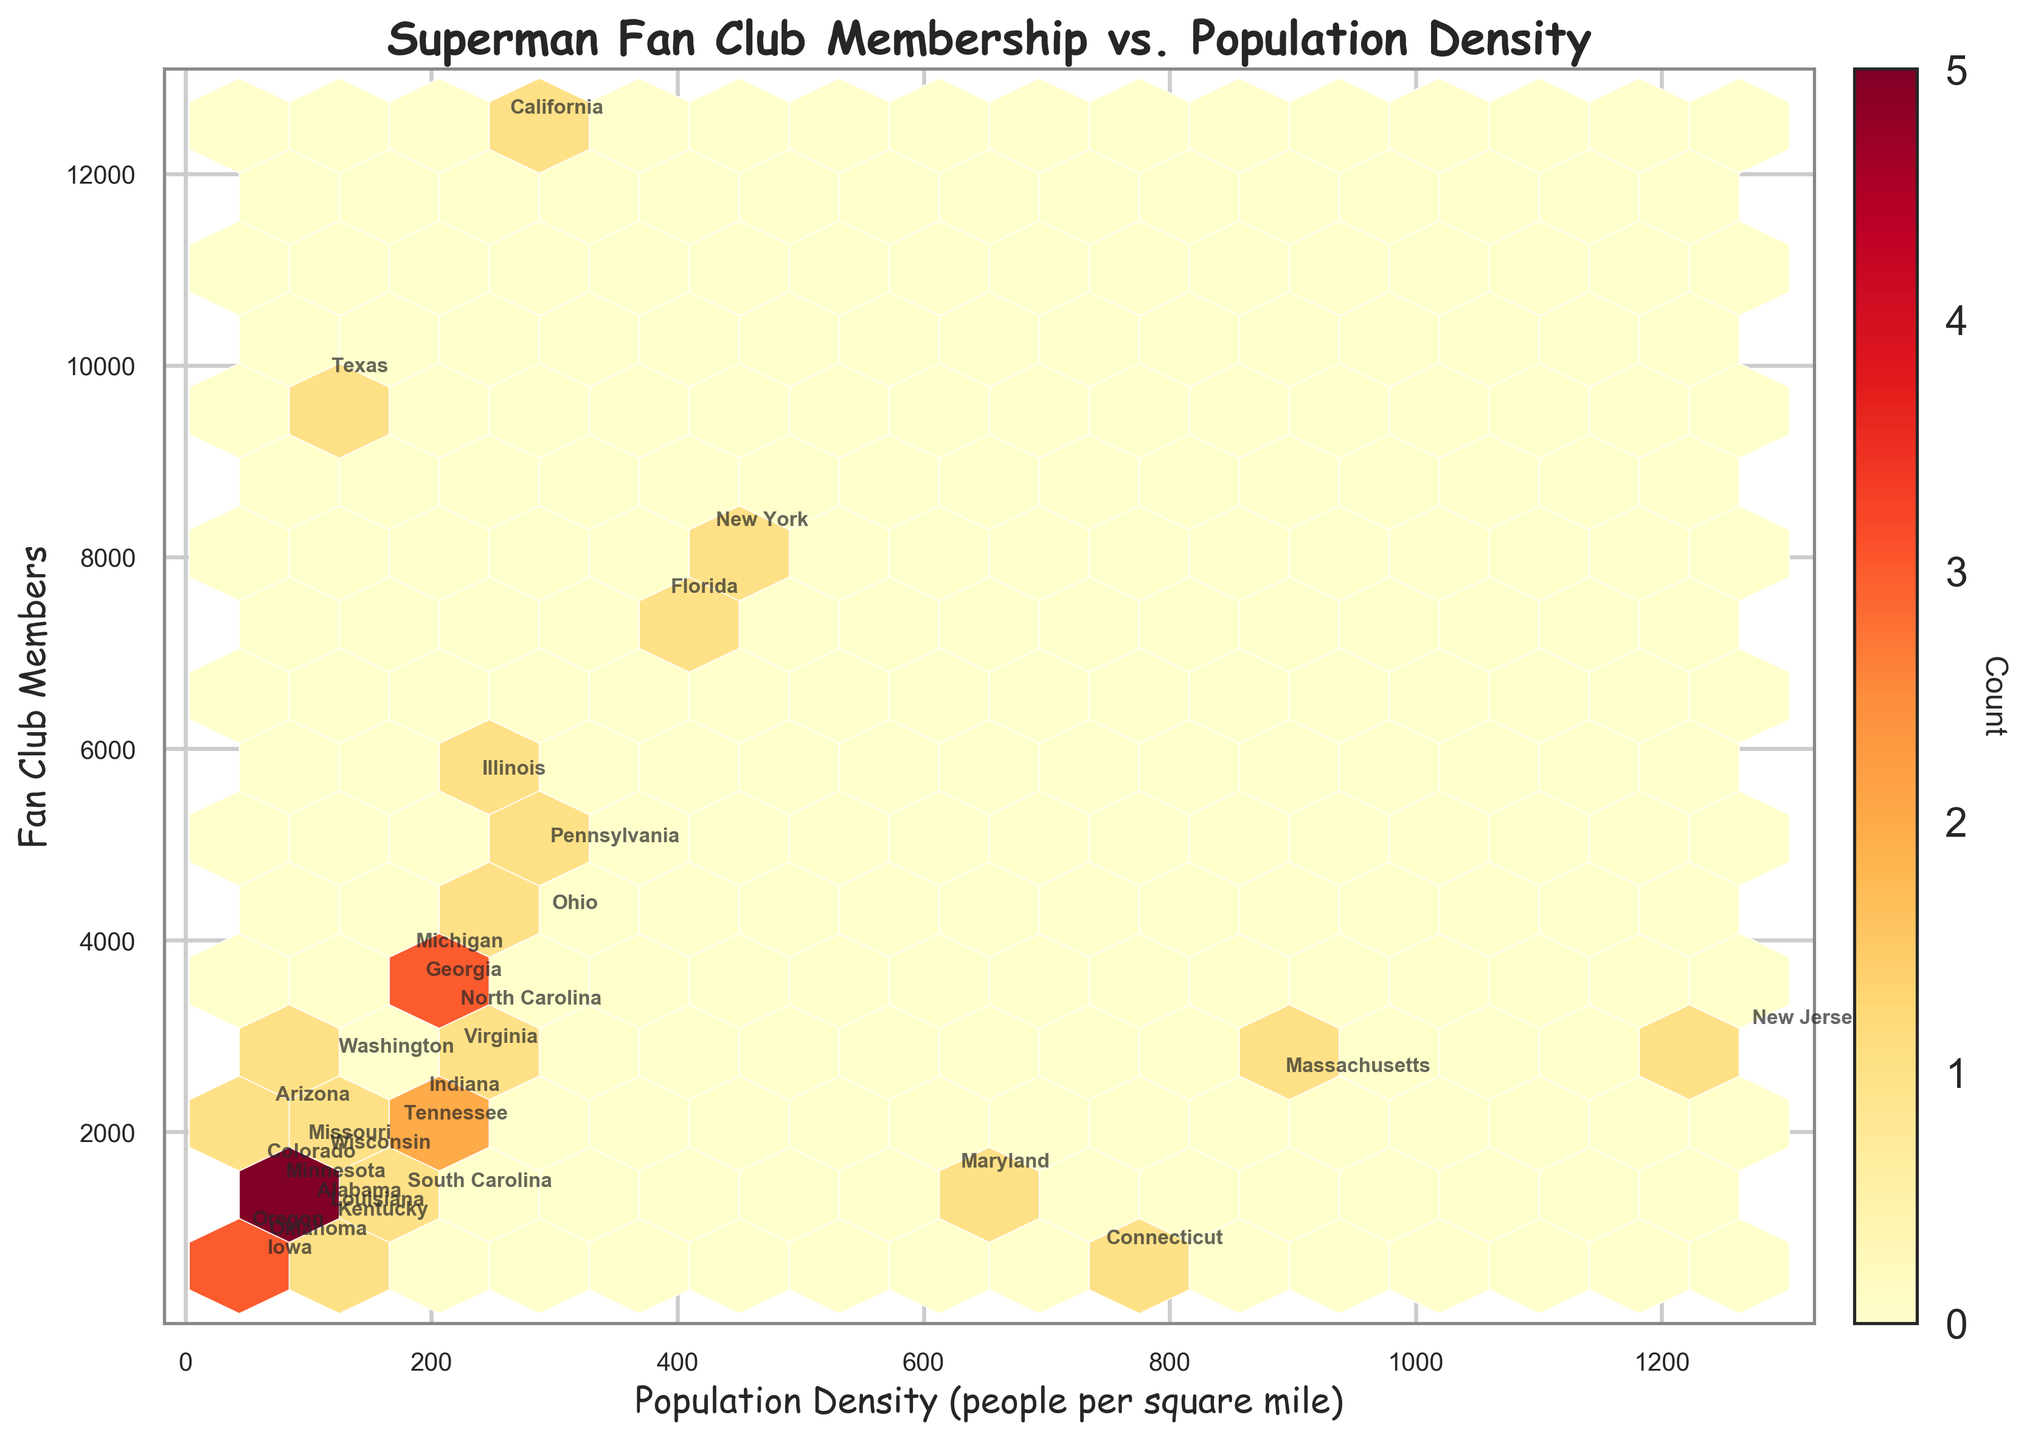What is the title of the plot? The title is often found at the top of the plot and provides a summary of what the plot represents.
Answer: "Superman Fan Club Membership vs. Population Density" What does the x-axis represent in the plot? The x-axis is labeled horizontally and indicates the measure being compared against the fan club members.
Answer: Population Density (people per square mile) What does the y-axis represent in the plot? The y-axis is labeled vertically and indicates the measure of fan club members being plotted.
Answer: Fan Club Members What color scheme is used in the hexbin plot? The plot uses a color scheme to represent the count of observations within each bin.
Answer: YlOrRd How many hexagonal bins are there along the x-axis? The grid size of the hexagonal bins visually segments the plot into multiple sections along the x-axis. The number of bins indicates the resolution of the distribution.
Answer: 15 Which state has the highest number of fan club members? By observing the data points and annotations, we can identify which state has the highest y-axis value.
Answer: California Which state has the highest population density? By observing the x-axis values and annotations, we can identify which state appears at the far right of the plot.
Answer: New Jersey Which states have more than 8000 fan club members? Look for data points that are above the 8000 mark on the y-axis and then note the annotations for those points.
Answer: California, Texas, New York Which regions seem to have the most concentrated points? Hexbin plots show areas of higher density with more saturated colors. Determine where the plot is most colorful.
Answer: The central to high-density population regions around 200-500 people per square mile Is there a trend between population density and the number of fan club members? Observe the overall pattern of the data points; if they rise together, there is a positive correlation.
Answer: Yes, there seems to be a slight positive trend where higher population densities have more fan club members What information does the color bar convey in this plot? The color bar is a gradient next to the plot that signifies how the color intensity relates to count values within the bins.
Answer: The color bar shows the count of data points within each hexbin 